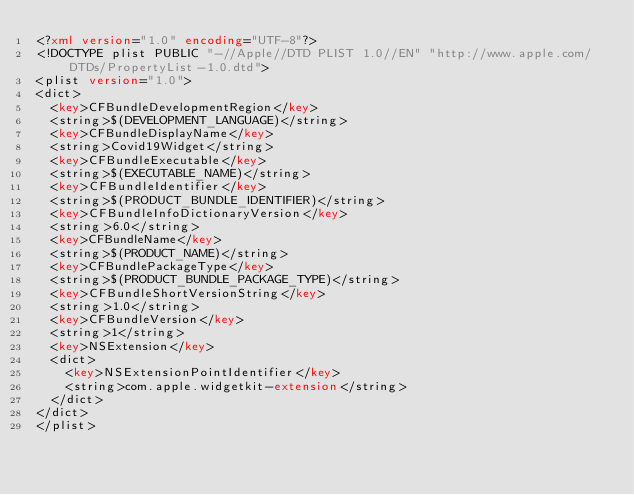Convert code to text. <code><loc_0><loc_0><loc_500><loc_500><_XML_><?xml version="1.0" encoding="UTF-8"?>
<!DOCTYPE plist PUBLIC "-//Apple//DTD PLIST 1.0//EN" "http://www.apple.com/DTDs/PropertyList-1.0.dtd">
<plist version="1.0">
<dict>
	<key>CFBundleDevelopmentRegion</key>
	<string>$(DEVELOPMENT_LANGUAGE)</string>
	<key>CFBundleDisplayName</key>
	<string>Covid19Widget</string>
	<key>CFBundleExecutable</key>
	<string>$(EXECUTABLE_NAME)</string>
	<key>CFBundleIdentifier</key>
	<string>$(PRODUCT_BUNDLE_IDENTIFIER)</string>
	<key>CFBundleInfoDictionaryVersion</key>
	<string>6.0</string>
	<key>CFBundleName</key>
	<string>$(PRODUCT_NAME)</string>
	<key>CFBundlePackageType</key>
	<string>$(PRODUCT_BUNDLE_PACKAGE_TYPE)</string>
	<key>CFBundleShortVersionString</key>
	<string>1.0</string>
	<key>CFBundleVersion</key>
	<string>1</string>
	<key>NSExtension</key>
	<dict>
		<key>NSExtensionPointIdentifier</key>
		<string>com.apple.widgetkit-extension</string>
	</dict>
</dict>
</plist>
</code> 